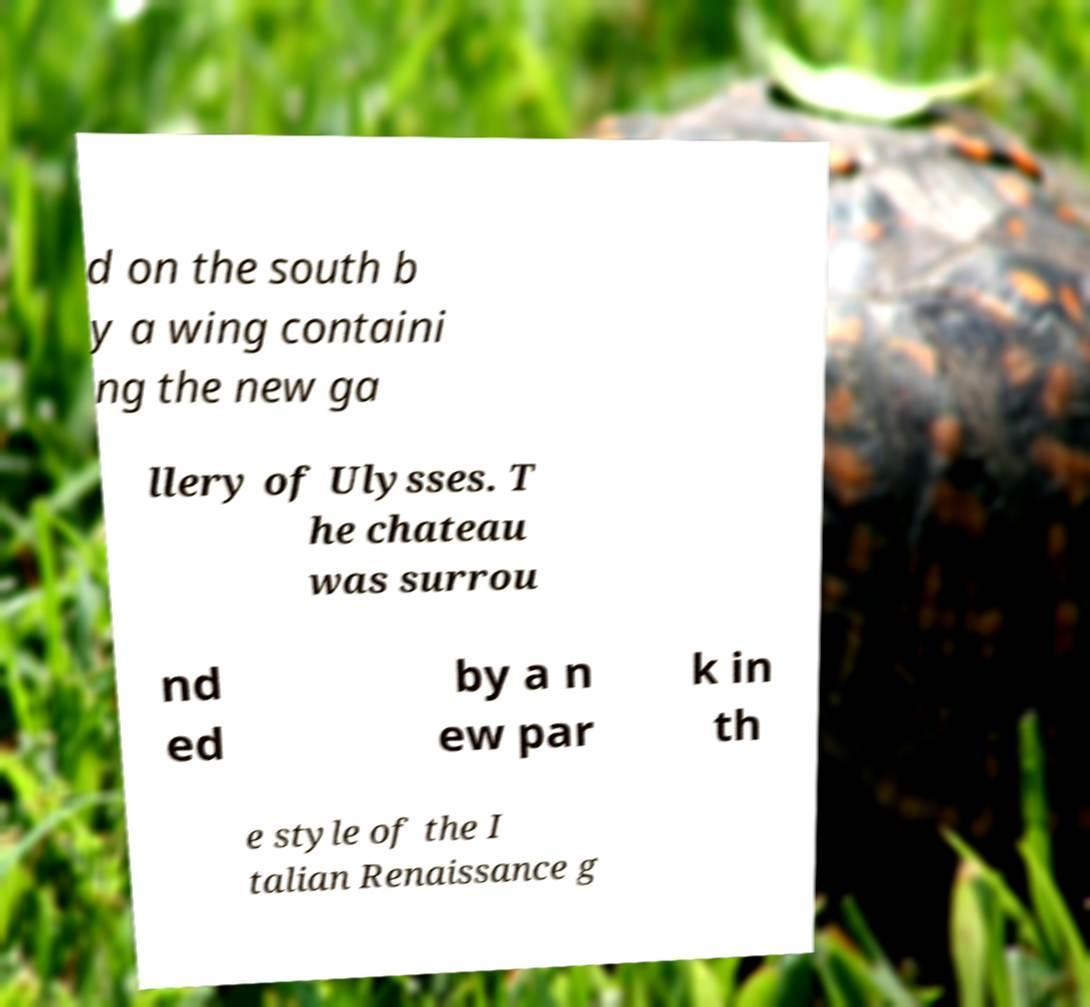Can you accurately transcribe the text from the provided image for me? d on the south b y a wing containi ng the new ga llery of Ulysses. T he chateau was surrou nd ed by a n ew par k in th e style of the I talian Renaissance g 